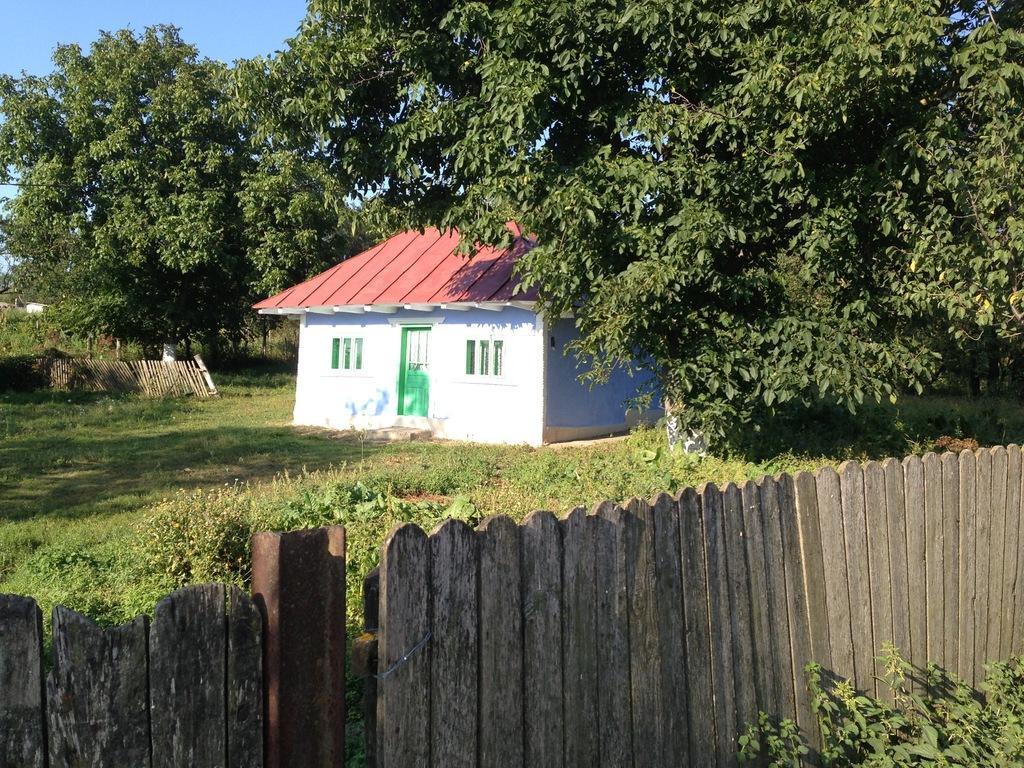Can you describe this image briefly? In this image we can see a house, fence, trees, grass and other objects. In the background of the image there is the sky. At the bottom of the image there is the fence and plants. 